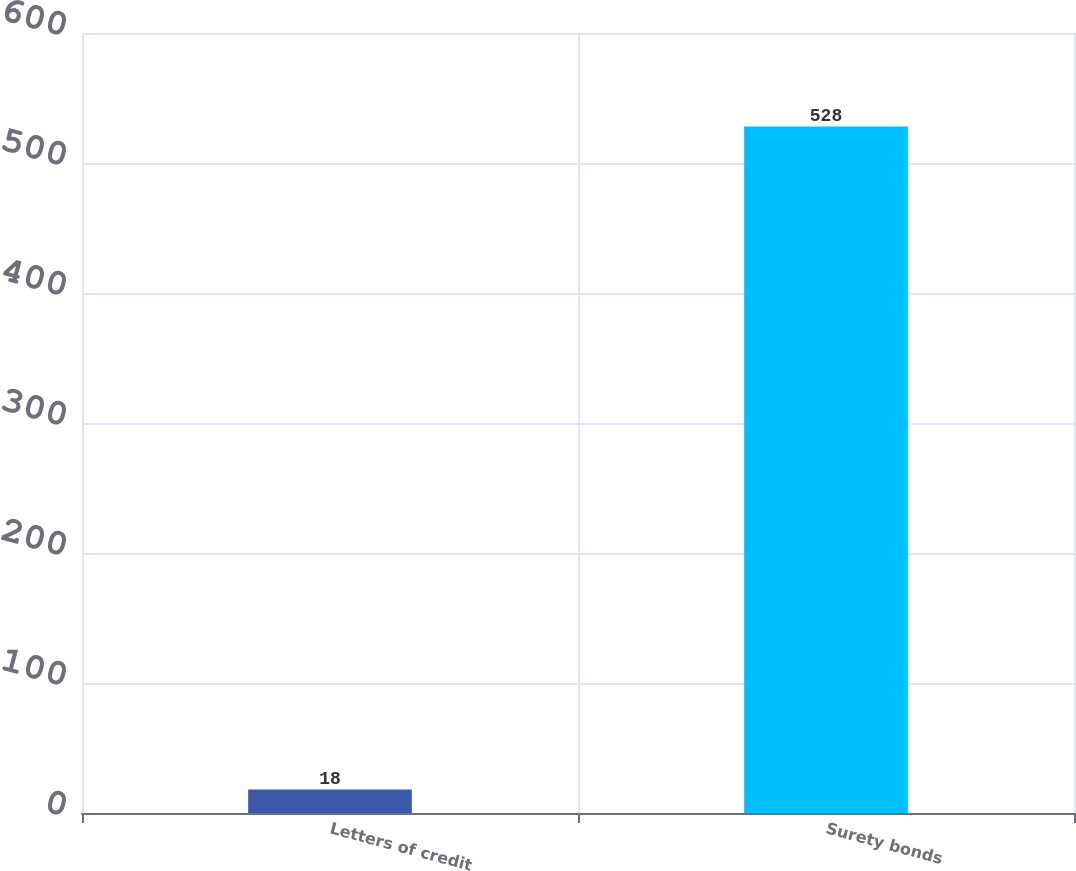Convert chart to OTSL. <chart><loc_0><loc_0><loc_500><loc_500><bar_chart><fcel>Letters of credit<fcel>Surety bonds<nl><fcel>18<fcel>528<nl></chart> 